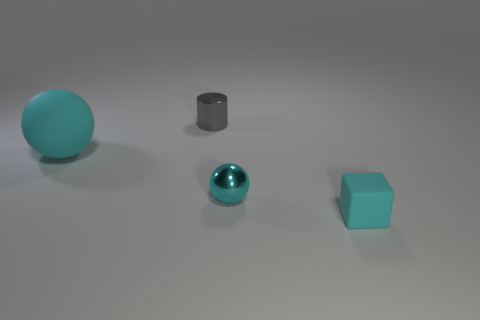Are there any other things that are the same shape as the tiny cyan rubber object?
Your answer should be very brief. No. There is a matte thing in front of the big cyan rubber object; what size is it?
Keep it short and to the point. Small. What is the small gray thing made of?
Offer a very short reply. Metal. What number of objects are balls that are right of the gray thing or things that are on the left side of the small shiny sphere?
Keep it short and to the point. 3. How many other objects are the same color as the rubber sphere?
Offer a very short reply. 2. There is a small gray thing; does it have the same shape as the matte object that is to the left of the tiny rubber thing?
Give a very brief answer. No. Is the number of cyan rubber cubes left of the metal cylinder less than the number of large things that are behind the rubber ball?
Provide a succinct answer. No. There is another cyan thing that is the same shape as the small cyan metal thing; what is it made of?
Provide a succinct answer. Rubber. Do the tiny rubber thing and the small cylinder have the same color?
Keep it short and to the point. No. What shape is the cyan object that is made of the same material as the large cyan sphere?
Make the answer very short. Cube. 